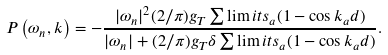<formula> <loc_0><loc_0><loc_500><loc_500>P \left ( \omega _ { n } , { k } \right ) = - \frac { | \omega _ { n } | ^ { 2 } ( 2 / \pi ) g _ { T } \sum \lim i t s _ { a } ( 1 - \cos k _ { a } d ) } { | \omega _ { n } | + ( 2 / \pi ) g _ { T } \delta \sum \lim i t s _ { a } ( 1 - \cos k _ { a } d ) } .</formula> 